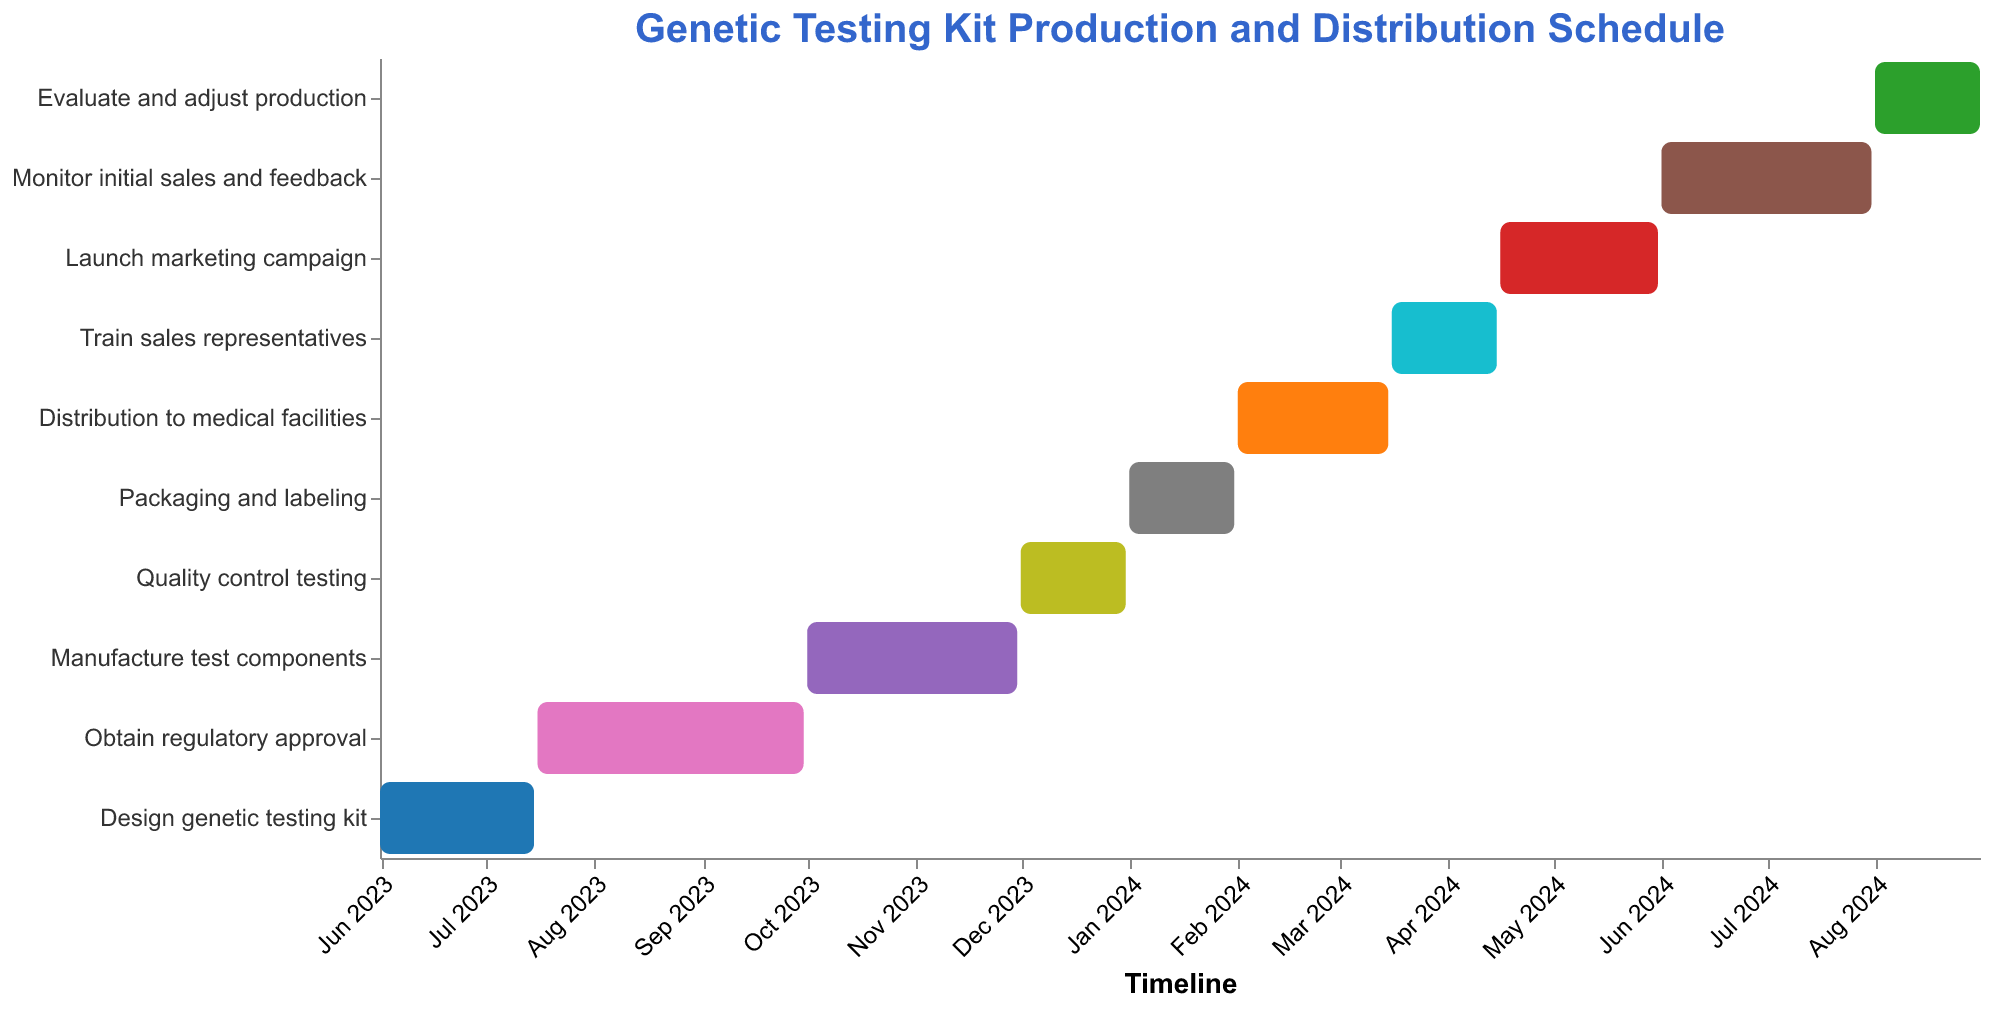What is the title of the chart? The title of the chart is displayed at the top within the title block.
Answer: Genetic Testing Kit Production and Distribution Schedule When does the "Design genetic testing kit" task begin and end? Refer to the starting and ending points of the bar labeled "Design genetic testing kit." The Start Date is June 1, 2023, and the End Date is July 15, 2023.
Answer: June 1, 2023, to July 15, 2023 Which task takes the longest duration to complete? Compare the lengths of all the bars in the chart. The longest bar represents the task "Obtain regulatory approval," which starts on July 16, 2023, and ends on September 30, 2023.
Answer: Obtain regulatory approval Which tasks are scheduled within the year 2024? Look at the tasks that have their start and end dates within 2024. The tasks are "Packaging and labeling," "Distribution to medical facilities," "Train sales representatives," "Launch marketing campaign," "Monitor initial sales and feedback," and "Evaluate and adjust production."
Answer: Packaging and labeling, Distribution to medical facilities, Train sales representatives, Launch marketing campaign, Monitor initial sales and feedback, Evaluate and adjust production How long is the distribution phase for the genetic testing kits? The distribution phase is labeled "Distribution to medical facilities." Note the start and end dates, then compute the difference. "Distribution to medical facilities" starts on February 1, 2024, and ends on March 15, 2024. There are 44 days between these dates.
Answer: 44 days What task occurs immediately after "Manufacture test components"? Observe the order of tasks on the chart. The task immediately following "Manufacture test components," which ends on November 30, 2023, is "Quality control testing," which starts on December 1, 2023.
Answer: Quality control testing Which task starts immediately after the "Launch marketing campaign"? The Gantt chart shows ordered tasks. Following "Launch marketing campaign," which ends on May 31, 2024, is "Monitor initial sales and feedback," which starts on June 1, 2024.
Answer: Monitor initial sales and feedback What is the range of dates covered by the entire production and distribution schedule? Identify the earliest start date and the latest end date in the chart. The earliest start date is June 1, 2023, and the latest end date is August 31, 2024.
Answer: June 1, 2023, to August 31, 2024 How many tasks are completed by the end of 2023? Count the bars that end on or before December 31, 2023. These tasks are "Design genetic testing kit," "Obtain regulatory approval," "Manufacture test components," and "Quality control testing." Therefore, four tasks are completed by the end of 2023.
Answer: Four tasks 